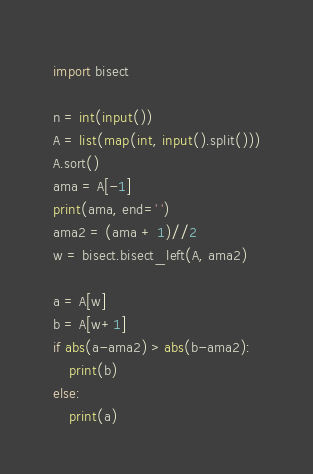<code> <loc_0><loc_0><loc_500><loc_500><_Python_>import bisect

n = int(input())
A = list(map(int, input().split()))
A.sort()
ama = A[-1]
print(ama, end=' ')
ama2 = (ama + 1)//2
w = bisect.bisect_left(A, ama2)

a = A[w]
b = A[w+1]
if abs(a-ama2) > abs(b-ama2):
    print(b)
else:
    print(a)
</code> 